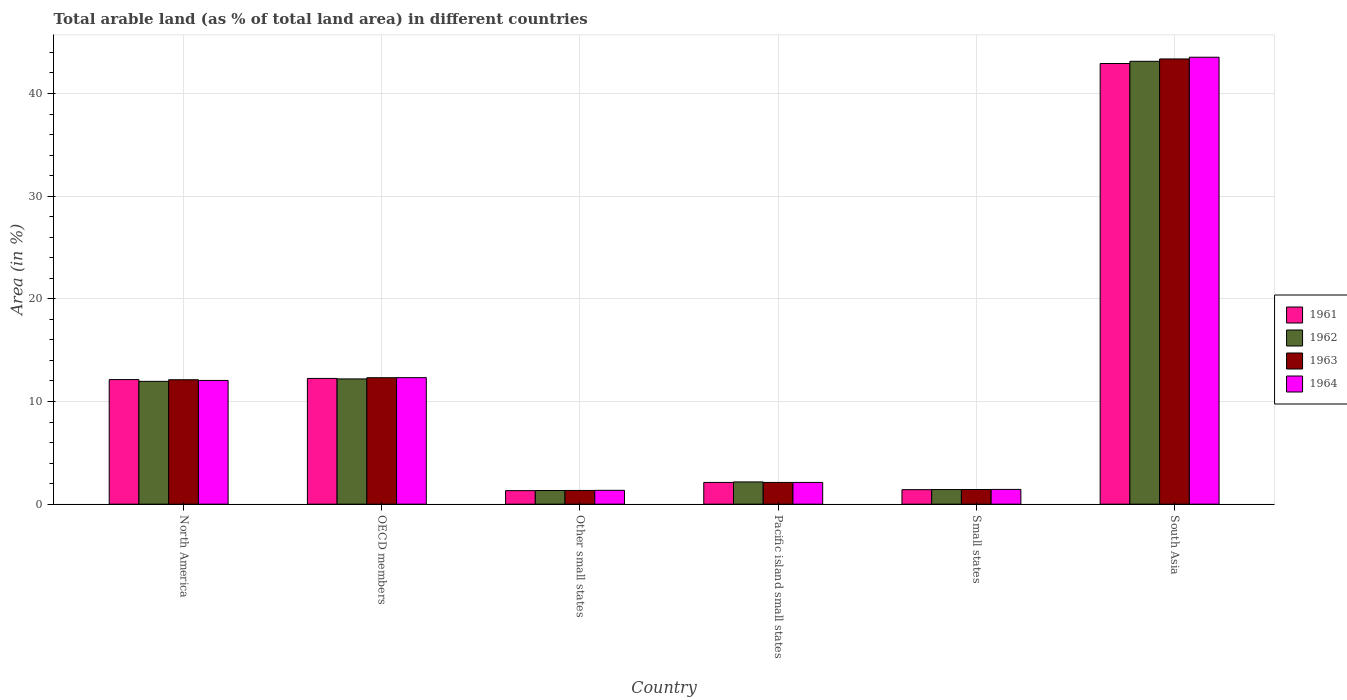How many groups of bars are there?
Your response must be concise. 6. How many bars are there on the 2nd tick from the left?
Give a very brief answer. 4. How many bars are there on the 4th tick from the right?
Offer a terse response. 4. What is the label of the 1st group of bars from the left?
Make the answer very short. North America. In how many cases, is the number of bars for a given country not equal to the number of legend labels?
Make the answer very short. 0. What is the percentage of arable land in 1962 in South Asia?
Give a very brief answer. 43.13. Across all countries, what is the maximum percentage of arable land in 1962?
Make the answer very short. 43.13. Across all countries, what is the minimum percentage of arable land in 1961?
Ensure brevity in your answer.  1.32. In which country was the percentage of arable land in 1963 maximum?
Provide a short and direct response. South Asia. In which country was the percentage of arable land in 1963 minimum?
Keep it short and to the point. Other small states. What is the total percentage of arable land in 1962 in the graph?
Give a very brief answer. 72.21. What is the difference between the percentage of arable land in 1964 in OECD members and that in Small states?
Your response must be concise. 10.89. What is the difference between the percentage of arable land in 1961 in North America and the percentage of arable land in 1963 in OECD members?
Your answer should be compact. -0.18. What is the average percentage of arable land in 1963 per country?
Offer a terse response. 12.11. What is the difference between the percentage of arable land of/in 1964 and percentage of arable land of/in 1962 in OECD members?
Provide a short and direct response. 0.12. In how many countries, is the percentage of arable land in 1964 greater than 22 %?
Keep it short and to the point. 1. What is the ratio of the percentage of arable land in 1962 in North America to that in OECD members?
Provide a short and direct response. 0.98. What is the difference between the highest and the second highest percentage of arable land in 1964?
Make the answer very short. 31.21. What is the difference between the highest and the lowest percentage of arable land in 1964?
Your answer should be compact. 42.18. In how many countries, is the percentage of arable land in 1964 greater than the average percentage of arable land in 1964 taken over all countries?
Provide a succinct answer. 2. Is the sum of the percentage of arable land in 1963 in Other small states and Pacific island small states greater than the maximum percentage of arable land in 1961 across all countries?
Make the answer very short. No. What does the 1st bar from the right in Other small states represents?
Provide a short and direct response. 1964. How many bars are there?
Keep it short and to the point. 24. Are all the bars in the graph horizontal?
Give a very brief answer. No. How many countries are there in the graph?
Make the answer very short. 6. Where does the legend appear in the graph?
Offer a very short reply. Center right. How are the legend labels stacked?
Offer a terse response. Vertical. What is the title of the graph?
Keep it short and to the point. Total arable land (as % of total land area) in different countries. What is the label or title of the X-axis?
Offer a terse response. Country. What is the label or title of the Y-axis?
Make the answer very short. Area (in %). What is the Area (in %) in 1961 in North America?
Make the answer very short. 12.13. What is the Area (in %) of 1962 in North America?
Make the answer very short. 11.96. What is the Area (in %) in 1963 in North America?
Offer a terse response. 12.12. What is the Area (in %) in 1964 in North America?
Keep it short and to the point. 12.05. What is the Area (in %) of 1961 in OECD members?
Give a very brief answer. 12.25. What is the Area (in %) in 1962 in OECD members?
Offer a very short reply. 12.2. What is the Area (in %) of 1963 in OECD members?
Offer a very short reply. 12.32. What is the Area (in %) of 1964 in OECD members?
Keep it short and to the point. 12.32. What is the Area (in %) of 1961 in Other small states?
Your answer should be compact. 1.32. What is the Area (in %) in 1962 in Other small states?
Provide a succinct answer. 1.33. What is the Area (in %) in 1963 in Other small states?
Your answer should be very brief. 1.34. What is the Area (in %) of 1964 in Other small states?
Offer a very short reply. 1.35. What is the Area (in %) in 1961 in Pacific island small states?
Make the answer very short. 2.12. What is the Area (in %) of 1962 in Pacific island small states?
Give a very brief answer. 2.17. What is the Area (in %) in 1963 in Pacific island small states?
Provide a succinct answer. 2.12. What is the Area (in %) in 1964 in Pacific island small states?
Provide a short and direct response. 2.12. What is the Area (in %) in 1961 in Small states?
Your answer should be very brief. 1.41. What is the Area (in %) in 1962 in Small states?
Provide a succinct answer. 1.42. What is the Area (in %) of 1963 in Small states?
Your answer should be very brief. 1.43. What is the Area (in %) of 1964 in Small states?
Keep it short and to the point. 1.44. What is the Area (in %) of 1961 in South Asia?
Provide a succinct answer. 42.92. What is the Area (in %) of 1962 in South Asia?
Your response must be concise. 43.13. What is the Area (in %) of 1963 in South Asia?
Make the answer very short. 43.36. What is the Area (in %) in 1964 in South Asia?
Your answer should be very brief. 43.53. Across all countries, what is the maximum Area (in %) in 1961?
Your answer should be very brief. 42.92. Across all countries, what is the maximum Area (in %) in 1962?
Ensure brevity in your answer.  43.13. Across all countries, what is the maximum Area (in %) in 1963?
Provide a short and direct response. 43.36. Across all countries, what is the maximum Area (in %) of 1964?
Your answer should be very brief. 43.53. Across all countries, what is the minimum Area (in %) of 1961?
Give a very brief answer. 1.32. Across all countries, what is the minimum Area (in %) in 1962?
Provide a succinct answer. 1.33. Across all countries, what is the minimum Area (in %) of 1963?
Provide a succinct answer. 1.34. Across all countries, what is the minimum Area (in %) of 1964?
Keep it short and to the point. 1.35. What is the total Area (in %) in 1961 in the graph?
Keep it short and to the point. 72.15. What is the total Area (in %) in 1962 in the graph?
Give a very brief answer. 72.21. What is the total Area (in %) in 1963 in the graph?
Keep it short and to the point. 72.68. What is the total Area (in %) in 1964 in the graph?
Provide a succinct answer. 72.81. What is the difference between the Area (in %) of 1961 in North America and that in OECD members?
Make the answer very short. -0.11. What is the difference between the Area (in %) in 1962 in North America and that in OECD members?
Provide a succinct answer. -0.24. What is the difference between the Area (in %) in 1963 in North America and that in OECD members?
Make the answer very short. -0.2. What is the difference between the Area (in %) of 1964 in North America and that in OECD members?
Your response must be concise. -0.27. What is the difference between the Area (in %) in 1961 in North America and that in Other small states?
Provide a succinct answer. 10.82. What is the difference between the Area (in %) in 1962 in North America and that in Other small states?
Your answer should be very brief. 10.63. What is the difference between the Area (in %) in 1963 in North America and that in Other small states?
Your answer should be very brief. 10.78. What is the difference between the Area (in %) in 1964 in North America and that in Other small states?
Your answer should be very brief. 10.7. What is the difference between the Area (in %) in 1961 in North America and that in Pacific island small states?
Provide a succinct answer. 10.02. What is the difference between the Area (in %) in 1962 in North America and that in Pacific island small states?
Give a very brief answer. 9.8. What is the difference between the Area (in %) in 1963 in North America and that in Pacific island small states?
Your response must be concise. 10. What is the difference between the Area (in %) of 1964 in North America and that in Pacific island small states?
Keep it short and to the point. 9.93. What is the difference between the Area (in %) in 1961 in North America and that in Small states?
Ensure brevity in your answer.  10.72. What is the difference between the Area (in %) in 1962 in North America and that in Small states?
Ensure brevity in your answer.  10.54. What is the difference between the Area (in %) of 1963 in North America and that in Small states?
Keep it short and to the point. 10.69. What is the difference between the Area (in %) in 1964 in North America and that in Small states?
Your answer should be compact. 10.61. What is the difference between the Area (in %) in 1961 in North America and that in South Asia?
Your answer should be very brief. -30.78. What is the difference between the Area (in %) in 1962 in North America and that in South Asia?
Offer a terse response. -31.17. What is the difference between the Area (in %) of 1963 in North America and that in South Asia?
Offer a terse response. -31.24. What is the difference between the Area (in %) of 1964 in North America and that in South Asia?
Ensure brevity in your answer.  -31.48. What is the difference between the Area (in %) of 1961 in OECD members and that in Other small states?
Your answer should be very brief. 10.93. What is the difference between the Area (in %) of 1962 in OECD members and that in Other small states?
Give a very brief answer. 10.87. What is the difference between the Area (in %) in 1963 in OECD members and that in Other small states?
Keep it short and to the point. 10.98. What is the difference between the Area (in %) of 1964 in OECD members and that in Other small states?
Offer a very short reply. 10.98. What is the difference between the Area (in %) in 1961 in OECD members and that in Pacific island small states?
Offer a very short reply. 10.13. What is the difference between the Area (in %) of 1962 in OECD members and that in Pacific island small states?
Your response must be concise. 10.03. What is the difference between the Area (in %) of 1963 in OECD members and that in Pacific island small states?
Your response must be concise. 10.2. What is the difference between the Area (in %) in 1964 in OECD members and that in Pacific island small states?
Provide a succinct answer. 10.2. What is the difference between the Area (in %) of 1961 in OECD members and that in Small states?
Offer a terse response. 10.83. What is the difference between the Area (in %) of 1962 in OECD members and that in Small states?
Your answer should be compact. 10.78. What is the difference between the Area (in %) in 1963 in OECD members and that in Small states?
Make the answer very short. 10.89. What is the difference between the Area (in %) in 1964 in OECD members and that in Small states?
Your answer should be very brief. 10.89. What is the difference between the Area (in %) in 1961 in OECD members and that in South Asia?
Provide a short and direct response. -30.67. What is the difference between the Area (in %) in 1962 in OECD members and that in South Asia?
Offer a terse response. -30.94. What is the difference between the Area (in %) of 1963 in OECD members and that in South Asia?
Offer a very short reply. -31.05. What is the difference between the Area (in %) in 1964 in OECD members and that in South Asia?
Offer a very short reply. -31.21. What is the difference between the Area (in %) of 1961 in Other small states and that in Pacific island small states?
Provide a succinct answer. -0.8. What is the difference between the Area (in %) of 1962 in Other small states and that in Pacific island small states?
Your response must be concise. -0.84. What is the difference between the Area (in %) in 1963 in Other small states and that in Pacific island small states?
Give a very brief answer. -0.78. What is the difference between the Area (in %) of 1964 in Other small states and that in Pacific island small states?
Your response must be concise. -0.77. What is the difference between the Area (in %) of 1961 in Other small states and that in Small states?
Your response must be concise. -0.09. What is the difference between the Area (in %) in 1962 in Other small states and that in Small states?
Keep it short and to the point. -0.09. What is the difference between the Area (in %) in 1963 in Other small states and that in Small states?
Make the answer very short. -0.09. What is the difference between the Area (in %) in 1964 in Other small states and that in Small states?
Keep it short and to the point. -0.09. What is the difference between the Area (in %) of 1961 in Other small states and that in South Asia?
Keep it short and to the point. -41.6. What is the difference between the Area (in %) of 1962 in Other small states and that in South Asia?
Your answer should be compact. -41.8. What is the difference between the Area (in %) of 1963 in Other small states and that in South Asia?
Give a very brief answer. -42.03. What is the difference between the Area (in %) in 1964 in Other small states and that in South Asia?
Your answer should be very brief. -42.18. What is the difference between the Area (in %) of 1961 in Pacific island small states and that in Small states?
Offer a very short reply. 0.71. What is the difference between the Area (in %) of 1962 in Pacific island small states and that in Small states?
Your answer should be compact. 0.74. What is the difference between the Area (in %) in 1963 in Pacific island small states and that in Small states?
Ensure brevity in your answer.  0.69. What is the difference between the Area (in %) of 1964 in Pacific island small states and that in Small states?
Ensure brevity in your answer.  0.68. What is the difference between the Area (in %) of 1961 in Pacific island small states and that in South Asia?
Provide a succinct answer. -40.8. What is the difference between the Area (in %) of 1962 in Pacific island small states and that in South Asia?
Provide a succinct answer. -40.97. What is the difference between the Area (in %) of 1963 in Pacific island small states and that in South Asia?
Ensure brevity in your answer.  -41.24. What is the difference between the Area (in %) of 1964 in Pacific island small states and that in South Asia?
Make the answer very short. -41.41. What is the difference between the Area (in %) of 1961 in Small states and that in South Asia?
Your answer should be compact. -41.51. What is the difference between the Area (in %) in 1962 in Small states and that in South Asia?
Offer a very short reply. -41.71. What is the difference between the Area (in %) of 1963 in Small states and that in South Asia?
Your answer should be compact. -41.94. What is the difference between the Area (in %) of 1964 in Small states and that in South Asia?
Offer a terse response. -42.09. What is the difference between the Area (in %) in 1961 in North America and the Area (in %) in 1962 in OECD members?
Keep it short and to the point. -0.06. What is the difference between the Area (in %) of 1961 in North America and the Area (in %) of 1963 in OECD members?
Ensure brevity in your answer.  -0.18. What is the difference between the Area (in %) in 1961 in North America and the Area (in %) in 1964 in OECD members?
Your response must be concise. -0.19. What is the difference between the Area (in %) of 1962 in North America and the Area (in %) of 1963 in OECD members?
Give a very brief answer. -0.36. What is the difference between the Area (in %) in 1962 in North America and the Area (in %) in 1964 in OECD members?
Offer a very short reply. -0.36. What is the difference between the Area (in %) in 1963 in North America and the Area (in %) in 1964 in OECD members?
Offer a terse response. -0.2. What is the difference between the Area (in %) in 1961 in North America and the Area (in %) in 1962 in Other small states?
Your response must be concise. 10.8. What is the difference between the Area (in %) of 1961 in North America and the Area (in %) of 1963 in Other small states?
Your answer should be compact. 10.8. What is the difference between the Area (in %) of 1961 in North America and the Area (in %) of 1964 in Other small states?
Your answer should be very brief. 10.79. What is the difference between the Area (in %) of 1962 in North America and the Area (in %) of 1963 in Other small states?
Ensure brevity in your answer.  10.63. What is the difference between the Area (in %) in 1962 in North America and the Area (in %) in 1964 in Other small states?
Make the answer very short. 10.61. What is the difference between the Area (in %) in 1963 in North America and the Area (in %) in 1964 in Other small states?
Keep it short and to the point. 10.77. What is the difference between the Area (in %) in 1961 in North America and the Area (in %) in 1962 in Pacific island small states?
Your answer should be very brief. 9.97. What is the difference between the Area (in %) of 1961 in North America and the Area (in %) of 1963 in Pacific island small states?
Provide a succinct answer. 10.02. What is the difference between the Area (in %) in 1961 in North America and the Area (in %) in 1964 in Pacific island small states?
Provide a short and direct response. 10.02. What is the difference between the Area (in %) in 1962 in North America and the Area (in %) in 1963 in Pacific island small states?
Make the answer very short. 9.84. What is the difference between the Area (in %) of 1962 in North America and the Area (in %) of 1964 in Pacific island small states?
Give a very brief answer. 9.84. What is the difference between the Area (in %) of 1963 in North America and the Area (in %) of 1964 in Pacific island small states?
Your answer should be compact. 10. What is the difference between the Area (in %) in 1961 in North America and the Area (in %) in 1962 in Small states?
Ensure brevity in your answer.  10.71. What is the difference between the Area (in %) of 1961 in North America and the Area (in %) of 1963 in Small states?
Your answer should be compact. 10.71. What is the difference between the Area (in %) of 1961 in North America and the Area (in %) of 1964 in Small states?
Give a very brief answer. 10.7. What is the difference between the Area (in %) of 1962 in North America and the Area (in %) of 1963 in Small states?
Your response must be concise. 10.53. What is the difference between the Area (in %) in 1962 in North America and the Area (in %) in 1964 in Small states?
Provide a succinct answer. 10.52. What is the difference between the Area (in %) of 1963 in North America and the Area (in %) of 1964 in Small states?
Make the answer very short. 10.68. What is the difference between the Area (in %) of 1961 in North America and the Area (in %) of 1962 in South Asia?
Make the answer very short. -31. What is the difference between the Area (in %) in 1961 in North America and the Area (in %) in 1963 in South Asia?
Keep it short and to the point. -31.23. What is the difference between the Area (in %) in 1961 in North America and the Area (in %) in 1964 in South Asia?
Offer a very short reply. -31.4. What is the difference between the Area (in %) in 1962 in North America and the Area (in %) in 1963 in South Asia?
Give a very brief answer. -31.4. What is the difference between the Area (in %) in 1962 in North America and the Area (in %) in 1964 in South Asia?
Make the answer very short. -31.57. What is the difference between the Area (in %) in 1963 in North America and the Area (in %) in 1964 in South Asia?
Give a very brief answer. -31.41. What is the difference between the Area (in %) of 1961 in OECD members and the Area (in %) of 1962 in Other small states?
Your answer should be compact. 10.92. What is the difference between the Area (in %) in 1961 in OECD members and the Area (in %) in 1963 in Other small states?
Keep it short and to the point. 10.91. What is the difference between the Area (in %) in 1961 in OECD members and the Area (in %) in 1964 in Other small states?
Give a very brief answer. 10.9. What is the difference between the Area (in %) of 1962 in OECD members and the Area (in %) of 1963 in Other small states?
Provide a short and direct response. 10.86. What is the difference between the Area (in %) in 1962 in OECD members and the Area (in %) in 1964 in Other small states?
Your response must be concise. 10.85. What is the difference between the Area (in %) of 1963 in OECD members and the Area (in %) of 1964 in Other small states?
Offer a terse response. 10.97. What is the difference between the Area (in %) in 1961 in OECD members and the Area (in %) in 1962 in Pacific island small states?
Ensure brevity in your answer.  10.08. What is the difference between the Area (in %) of 1961 in OECD members and the Area (in %) of 1963 in Pacific island small states?
Offer a very short reply. 10.13. What is the difference between the Area (in %) in 1961 in OECD members and the Area (in %) in 1964 in Pacific island small states?
Your response must be concise. 10.13. What is the difference between the Area (in %) of 1962 in OECD members and the Area (in %) of 1963 in Pacific island small states?
Your answer should be very brief. 10.08. What is the difference between the Area (in %) in 1962 in OECD members and the Area (in %) in 1964 in Pacific island small states?
Your response must be concise. 10.08. What is the difference between the Area (in %) of 1963 in OECD members and the Area (in %) of 1964 in Pacific island small states?
Make the answer very short. 10.2. What is the difference between the Area (in %) of 1961 in OECD members and the Area (in %) of 1962 in Small states?
Your answer should be very brief. 10.82. What is the difference between the Area (in %) in 1961 in OECD members and the Area (in %) in 1963 in Small states?
Make the answer very short. 10.82. What is the difference between the Area (in %) of 1961 in OECD members and the Area (in %) of 1964 in Small states?
Make the answer very short. 10.81. What is the difference between the Area (in %) in 1962 in OECD members and the Area (in %) in 1963 in Small states?
Offer a very short reply. 10.77. What is the difference between the Area (in %) of 1962 in OECD members and the Area (in %) of 1964 in Small states?
Provide a succinct answer. 10.76. What is the difference between the Area (in %) in 1963 in OECD members and the Area (in %) in 1964 in Small states?
Offer a terse response. 10.88. What is the difference between the Area (in %) in 1961 in OECD members and the Area (in %) in 1962 in South Asia?
Keep it short and to the point. -30.89. What is the difference between the Area (in %) in 1961 in OECD members and the Area (in %) in 1963 in South Asia?
Offer a terse response. -31.12. What is the difference between the Area (in %) of 1961 in OECD members and the Area (in %) of 1964 in South Asia?
Your answer should be compact. -31.28. What is the difference between the Area (in %) in 1962 in OECD members and the Area (in %) in 1963 in South Asia?
Your response must be concise. -31.16. What is the difference between the Area (in %) of 1962 in OECD members and the Area (in %) of 1964 in South Asia?
Offer a terse response. -31.33. What is the difference between the Area (in %) of 1963 in OECD members and the Area (in %) of 1964 in South Asia?
Provide a short and direct response. -31.21. What is the difference between the Area (in %) in 1961 in Other small states and the Area (in %) in 1962 in Pacific island small states?
Offer a very short reply. -0.85. What is the difference between the Area (in %) of 1961 in Other small states and the Area (in %) of 1963 in Pacific island small states?
Make the answer very short. -0.8. What is the difference between the Area (in %) in 1961 in Other small states and the Area (in %) in 1964 in Pacific island small states?
Your answer should be compact. -0.8. What is the difference between the Area (in %) in 1962 in Other small states and the Area (in %) in 1963 in Pacific island small states?
Make the answer very short. -0.79. What is the difference between the Area (in %) of 1962 in Other small states and the Area (in %) of 1964 in Pacific island small states?
Give a very brief answer. -0.79. What is the difference between the Area (in %) in 1963 in Other small states and the Area (in %) in 1964 in Pacific island small states?
Give a very brief answer. -0.78. What is the difference between the Area (in %) in 1961 in Other small states and the Area (in %) in 1962 in Small states?
Ensure brevity in your answer.  -0.1. What is the difference between the Area (in %) in 1961 in Other small states and the Area (in %) in 1963 in Small states?
Make the answer very short. -0.11. What is the difference between the Area (in %) in 1961 in Other small states and the Area (in %) in 1964 in Small states?
Your answer should be very brief. -0.12. What is the difference between the Area (in %) in 1962 in Other small states and the Area (in %) in 1963 in Small states?
Offer a very short reply. -0.1. What is the difference between the Area (in %) in 1962 in Other small states and the Area (in %) in 1964 in Small states?
Provide a succinct answer. -0.11. What is the difference between the Area (in %) in 1963 in Other small states and the Area (in %) in 1964 in Small states?
Provide a short and direct response. -0.1. What is the difference between the Area (in %) in 1961 in Other small states and the Area (in %) in 1962 in South Asia?
Your answer should be compact. -41.82. What is the difference between the Area (in %) of 1961 in Other small states and the Area (in %) of 1963 in South Asia?
Offer a very short reply. -42.04. What is the difference between the Area (in %) in 1961 in Other small states and the Area (in %) in 1964 in South Asia?
Your response must be concise. -42.21. What is the difference between the Area (in %) of 1962 in Other small states and the Area (in %) of 1963 in South Asia?
Offer a terse response. -42.03. What is the difference between the Area (in %) in 1962 in Other small states and the Area (in %) in 1964 in South Asia?
Your answer should be compact. -42.2. What is the difference between the Area (in %) in 1963 in Other small states and the Area (in %) in 1964 in South Asia?
Ensure brevity in your answer.  -42.2. What is the difference between the Area (in %) in 1961 in Pacific island small states and the Area (in %) in 1962 in Small states?
Provide a succinct answer. 0.69. What is the difference between the Area (in %) of 1961 in Pacific island small states and the Area (in %) of 1963 in Small states?
Provide a short and direct response. 0.69. What is the difference between the Area (in %) of 1961 in Pacific island small states and the Area (in %) of 1964 in Small states?
Your answer should be very brief. 0.68. What is the difference between the Area (in %) of 1962 in Pacific island small states and the Area (in %) of 1963 in Small states?
Provide a short and direct response. 0.74. What is the difference between the Area (in %) of 1962 in Pacific island small states and the Area (in %) of 1964 in Small states?
Your response must be concise. 0.73. What is the difference between the Area (in %) of 1963 in Pacific island small states and the Area (in %) of 1964 in Small states?
Your response must be concise. 0.68. What is the difference between the Area (in %) of 1961 in Pacific island small states and the Area (in %) of 1962 in South Asia?
Offer a terse response. -41.02. What is the difference between the Area (in %) of 1961 in Pacific island small states and the Area (in %) of 1963 in South Asia?
Offer a very short reply. -41.24. What is the difference between the Area (in %) of 1961 in Pacific island small states and the Area (in %) of 1964 in South Asia?
Your answer should be compact. -41.41. What is the difference between the Area (in %) in 1962 in Pacific island small states and the Area (in %) in 1963 in South Asia?
Provide a succinct answer. -41.2. What is the difference between the Area (in %) in 1962 in Pacific island small states and the Area (in %) in 1964 in South Asia?
Keep it short and to the point. -41.37. What is the difference between the Area (in %) in 1963 in Pacific island small states and the Area (in %) in 1964 in South Asia?
Give a very brief answer. -41.41. What is the difference between the Area (in %) in 1961 in Small states and the Area (in %) in 1962 in South Asia?
Ensure brevity in your answer.  -41.72. What is the difference between the Area (in %) of 1961 in Small states and the Area (in %) of 1963 in South Asia?
Keep it short and to the point. -41.95. What is the difference between the Area (in %) in 1961 in Small states and the Area (in %) in 1964 in South Asia?
Your answer should be very brief. -42.12. What is the difference between the Area (in %) of 1962 in Small states and the Area (in %) of 1963 in South Asia?
Your answer should be very brief. -41.94. What is the difference between the Area (in %) in 1962 in Small states and the Area (in %) in 1964 in South Asia?
Your response must be concise. -42.11. What is the difference between the Area (in %) in 1963 in Small states and the Area (in %) in 1964 in South Asia?
Give a very brief answer. -42.1. What is the average Area (in %) in 1961 per country?
Your response must be concise. 12.02. What is the average Area (in %) in 1962 per country?
Offer a terse response. 12.04. What is the average Area (in %) of 1963 per country?
Your answer should be very brief. 12.11. What is the average Area (in %) in 1964 per country?
Provide a short and direct response. 12.13. What is the difference between the Area (in %) of 1961 and Area (in %) of 1962 in North America?
Offer a terse response. 0.17. What is the difference between the Area (in %) in 1961 and Area (in %) in 1963 in North America?
Your answer should be compact. 0.02. What is the difference between the Area (in %) in 1961 and Area (in %) in 1964 in North America?
Your answer should be compact. 0.08. What is the difference between the Area (in %) in 1962 and Area (in %) in 1963 in North America?
Provide a short and direct response. -0.16. What is the difference between the Area (in %) in 1962 and Area (in %) in 1964 in North America?
Provide a succinct answer. -0.09. What is the difference between the Area (in %) in 1963 and Area (in %) in 1964 in North America?
Provide a short and direct response. 0.07. What is the difference between the Area (in %) of 1961 and Area (in %) of 1962 in OECD members?
Your answer should be compact. 0.05. What is the difference between the Area (in %) of 1961 and Area (in %) of 1963 in OECD members?
Keep it short and to the point. -0.07. What is the difference between the Area (in %) of 1961 and Area (in %) of 1964 in OECD members?
Provide a succinct answer. -0.08. What is the difference between the Area (in %) of 1962 and Area (in %) of 1963 in OECD members?
Your answer should be very brief. -0.12. What is the difference between the Area (in %) of 1962 and Area (in %) of 1964 in OECD members?
Ensure brevity in your answer.  -0.12. What is the difference between the Area (in %) of 1963 and Area (in %) of 1964 in OECD members?
Your answer should be very brief. -0.01. What is the difference between the Area (in %) of 1961 and Area (in %) of 1962 in Other small states?
Offer a very short reply. -0.01. What is the difference between the Area (in %) of 1961 and Area (in %) of 1963 in Other small states?
Your answer should be very brief. -0.02. What is the difference between the Area (in %) of 1961 and Area (in %) of 1964 in Other small states?
Keep it short and to the point. -0.03. What is the difference between the Area (in %) of 1962 and Area (in %) of 1963 in Other small states?
Provide a succinct answer. -0.01. What is the difference between the Area (in %) of 1962 and Area (in %) of 1964 in Other small states?
Your answer should be very brief. -0.02. What is the difference between the Area (in %) in 1963 and Area (in %) in 1964 in Other small states?
Ensure brevity in your answer.  -0.01. What is the difference between the Area (in %) of 1961 and Area (in %) of 1962 in Pacific island small states?
Your response must be concise. -0.05. What is the difference between the Area (in %) of 1961 and Area (in %) of 1963 in Pacific island small states?
Keep it short and to the point. 0. What is the difference between the Area (in %) in 1961 and Area (in %) in 1964 in Pacific island small states?
Your response must be concise. 0. What is the difference between the Area (in %) in 1962 and Area (in %) in 1963 in Pacific island small states?
Offer a terse response. 0.05. What is the difference between the Area (in %) in 1962 and Area (in %) in 1964 in Pacific island small states?
Your answer should be compact. 0.05. What is the difference between the Area (in %) of 1961 and Area (in %) of 1962 in Small states?
Provide a succinct answer. -0.01. What is the difference between the Area (in %) in 1961 and Area (in %) in 1963 in Small states?
Ensure brevity in your answer.  -0.02. What is the difference between the Area (in %) of 1961 and Area (in %) of 1964 in Small states?
Your response must be concise. -0.03. What is the difference between the Area (in %) in 1962 and Area (in %) in 1963 in Small states?
Offer a terse response. -0. What is the difference between the Area (in %) of 1962 and Area (in %) of 1964 in Small states?
Make the answer very short. -0.01. What is the difference between the Area (in %) in 1963 and Area (in %) in 1964 in Small states?
Make the answer very short. -0.01. What is the difference between the Area (in %) of 1961 and Area (in %) of 1962 in South Asia?
Provide a succinct answer. -0.22. What is the difference between the Area (in %) of 1961 and Area (in %) of 1963 in South Asia?
Your response must be concise. -0.44. What is the difference between the Area (in %) in 1961 and Area (in %) in 1964 in South Asia?
Your response must be concise. -0.61. What is the difference between the Area (in %) in 1962 and Area (in %) in 1963 in South Asia?
Offer a terse response. -0.23. What is the difference between the Area (in %) in 1962 and Area (in %) in 1964 in South Asia?
Offer a terse response. -0.4. What is the difference between the Area (in %) in 1963 and Area (in %) in 1964 in South Asia?
Your answer should be very brief. -0.17. What is the ratio of the Area (in %) in 1961 in North America to that in OECD members?
Make the answer very short. 0.99. What is the ratio of the Area (in %) of 1962 in North America to that in OECD members?
Offer a terse response. 0.98. What is the ratio of the Area (in %) of 1963 in North America to that in OECD members?
Offer a very short reply. 0.98. What is the ratio of the Area (in %) of 1964 in North America to that in OECD members?
Offer a terse response. 0.98. What is the ratio of the Area (in %) in 1961 in North America to that in Other small states?
Provide a short and direct response. 9.21. What is the ratio of the Area (in %) of 1962 in North America to that in Other small states?
Offer a very short reply. 8.99. What is the ratio of the Area (in %) of 1963 in North America to that in Other small states?
Make the answer very short. 9.07. What is the ratio of the Area (in %) in 1964 in North America to that in Other small states?
Provide a succinct answer. 8.95. What is the ratio of the Area (in %) of 1961 in North America to that in Pacific island small states?
Your answer should be very brief. 5.73. What is the ratio of the Area (in %) in 1962 in North America to that in Pacific island small states?
Keep it short and to the point. 5.52. What is the ratio of the Area (in %) of 1963 in North America to that in Pacific island small states?
Provide a short and direct response. 5.72. What is the ratio of the Area (in %) of 1964 in North America to that in Pacific island small states?
Give a very brief answer. 5.69. What is the ratio of the Area (in %) in 1961 in North America to that in Small states?
Provide a succinct answer. 8.6. What is the ratio of the Area (in %) of 1962 in North America to that in Small states?
Your answer should be compact. 8.41. What is the ratio of the Area (in %) in 1963 in North America to that in Small states?
Offer a terse response. 8.49. What is the ratio of the Area (in %) of 1964 in North America to that in Small states?
Ensure brevity in your answer.  8.39. What is the ratio of the Area (in %) in 1961 in North America to that in South Asia?
Your response must be concise. 0.28. What is the ratio of the Area (in %) of 1962 in North America to that in South Asia?
Your answer should be compact. 0.28. What is the ratio of the Area (in %) of 1963 in North America to that in South Asia?
Your response must be concise. 0.28. What is the ratio of the Area (in %) of 1964 in North America to that in South Asia?
Make the answer very short. 0.28. What is the ratio of the Area (in %) of 1961 in OECD members to that in Other small states?
Provide a short and direct response. 9.29. What is the ratio of the Area (in %) in 1962 in OECD members to that in Other small states?
Keep it short and to the point. 9.17. What is the ratio of the Area (in %) in 1963 in OECD members to that in Other small states?
Provide a short and direct response. 9.22. What is the ratio of the Area (in %) of 1964 in OECD members to that in Other small states?
Provide a short and direct response. 9.15. What is the ratio of the Area (in %) of 1961 in OECD members to that in Pacific island small states?
Your answer should be compact. 5.78. What is the ratio of the Area (in %) of 1962 in OECD members to that in Pacific island small states?
Offer a very short reply. 5.63. What is the ratio of the Area (in %) of 1963 in OECD members to that in Pacific island small states?
Make the answer very short. 5.82. What is the ratio of the Area (in %) in 1964 in OECD members to that in Pacific island small states?
Offer a very short reply. 5.82. What is the ratio of the Area (in %) of 1961 in OECD members to that in Small states?
Ensure brevity in your answer.  8.68. What is the ratio of the Area (in %) of 1962 in OECD members to that in Small states?
Provide a short and direct response. 8.57. What is the ratio of the Area (in %) of 1963 in OECD members to that in Small states?
Offer a very short reply. 8.63. What is the ratio of the Area (in %) of 1964 in OECD members to that in Small states?
Ensure brevity in your answer.  8.57. What is the ratio of the Area (in %) of 1961 in OECD members to that in South Asia?
Give a very brief answer. 0.29. What is the ratio of the Area (in %) of 1962 in OECD members to that in South Asia?
Your response must be concise. 0.28. What is the ratio of the Area (in %) of 1963 in OECD members to that in South Asia?
Keep it short and to the point. 0.28. What is the ratio of the Area (in %) in 1964 in OECD members to that in South Asia?
Make the answer very short. 0.28. What is the ratio of the Area (in %) of 1961 in Other small states to that in Pacific island small states?
Your answer should be compact. 0.62. What is the ratio of the Area (in %) in 1962 in Other small states to that in Pacific island small states?
Provide a succinct answer. 0.61. What is the ratio of the Area (in %) in 1963 in Other small states to that in Pacific island small states?
Give a very brief answer. 0.63. What is the ratio of the Area (in %) in 1964 in Other small states to that in Pacific island small states?
Your answer should be very brief. 0.64. What is the ratio of the Area (in %) in 1961 in Other small states to that in Small states?
Offer a terse response. 0.93. What is the ratio of the Area (in %) in 1962 in Other small states to that in Small states?
Your answer should be very brief. 0.93. What is the ratio of the Area (in %) in 1963 in Other small states to that in Small states?
Your answer should be very brief. 0.94. What is the ratio of the Area (in %) of 1964 in Other small states to that in Small states?
Ensure brevity in your answer.  0.94. What is the ratio of the Area (in %) in 1961 in Other small states to that in South Asia?
Provide a succinct answer. 0.03. What is the ratio of the Area (in %) in 1962 in Other small states to that in South Asia?
Keep it short and to the point. 0.03. What is the ratio of the Area (in %) in 1963 in Other small states to that in South Asia?
Your answer should be compact. 0.03. What is the ratio of the Area (in %) in 1964 in Other small states to that in South Asia?
Your response must be concise. 0.03. What is the ratio of the Area (in %) in 1961 in Pacific island small states to that in Small states?
Provide a short and direct response. 1.5. What is the ratio of the Area (in %) of 1962 in Pacific island small states to that in Small states?
Your answer should be compact. 1.52. What is the ratio of the Area (in %) in 1963 in Pacific island small states to that in Small states?
Your answer should be compact. 1.48. What is the ratio of the Area (in %) of 1964 in Pacific island small states to that in Small states?
Offer a terse response. 1.47. What is the ratio of the Area (in %) of 1961 in Pacific island small states to that in South Asia?
Offer a terse response. 0.05. What is the ratio of the Area (in %) of 1962 in Pacific island small states to that in South Asia?
Offer a terse response. 0.05. What is the ratio of the Area (in %) of 1963 in Pacific island small states to that in South Asia?
Keep it short and to the point. 0.05. What is the ratio of the Area (in %) of 1964 in Pacific island small states to that in South Asia?
Your response must be concise. 0.05. What is the ratio of the Area (in %) in 1961 in Small states to that in South Asia?
Make the answer very short. 0.03. What is the ratio of the Area (in %) of 1962 in Small states to that in South Asia?
Your response must be concise. 0.03. What is the ratio of the Area (in %) in 1963 in Small states to that in South Asia?
Provide a short and direct response. 0.03. What is the ratio of the Area (in %) of 1964 in Small states to that in South Asia?
Your answer should be compact. 0.03. What is the difference between the highest and the second highest Area (in %) of 1961?
Keep it short and to the point. 30.67. What is the difference between the highest and the second highest Area (in %) in 1962?
Provide a succinct answer. 30.94. What is the difference between the highest and the second highest Area (in %) in 1963?
Your answer should be very brief. 31.05. What is the difference between the highest and the second highest Area (in %) of 1964?
Keep it short and to the point. 31.21. What is the difference between the highest and the lowest Area (in %) in 1961?
Offer a terse response. 41.6. What is the difference between the highest and the lowest Area (in %) of 1962?
Offer a very short reply. 41.8. What is the difference between the highest and the lowest Area (in %) of 1963?
Keep it short and to the point. 42.03. What is the difference between the highest and the lowest Area (in %) of 1964?
Your answer should be very brief. 42.18. 